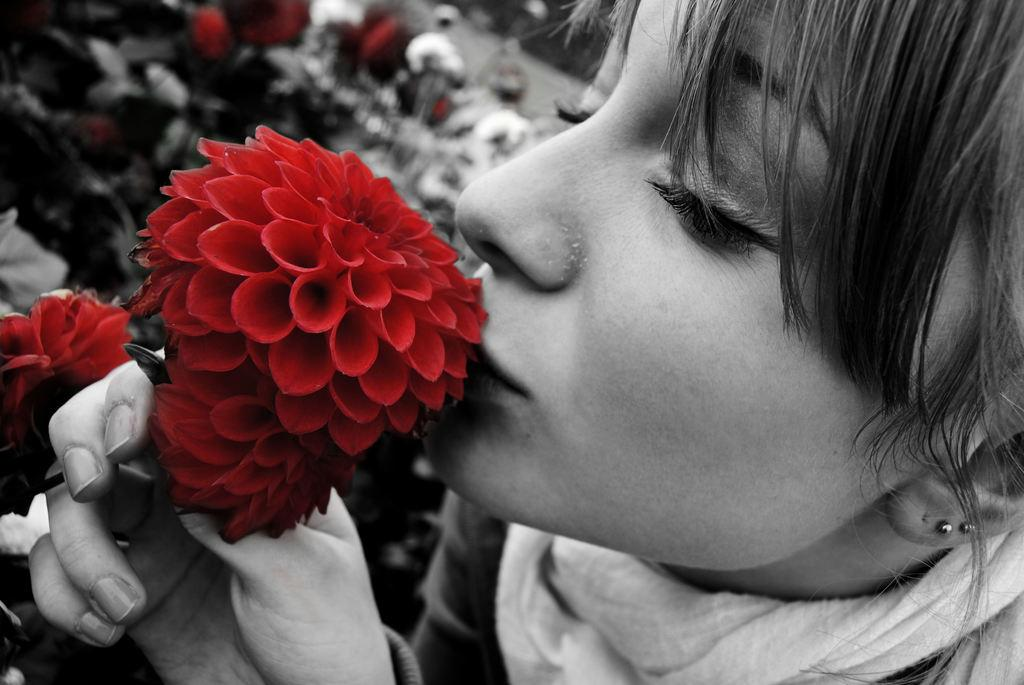What is the color scheme of the image? The image is black and white. Who is present in the image? There is a woman in the image. What is the woman holding? The woman is holding a flower. Can you describe the background of the image? There are blurred items in the background of the image. What type of pen is the woman using to write a birthday message in the image? There is no pen or birthday message present in the image; it features a woman holding a flower. Is the woman taking a bath in the image? There is no indication of a bath or any water-related activity in the image. 